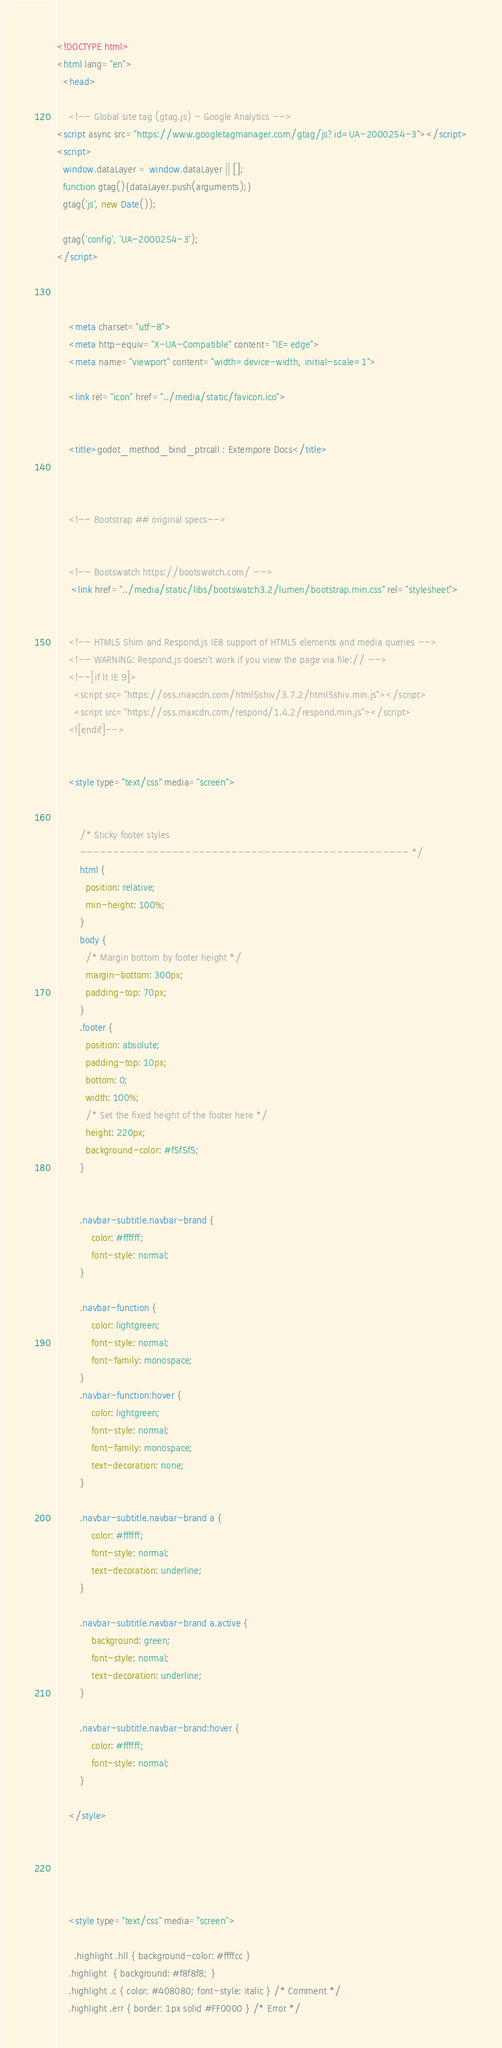Convert code to text. <code><loc_0><loc_0><loc_500><loc_500><_HTML_>




<!DOCTYPE html>
<html lang="en">
  <head>

	<!-- Global site tag (gtag.js) - Google Analytics -->
<script async src="https://www.googletagmanager.com/gtag/js?id=UA-2000254-3"></script>
<script>
  window.dataLayer = window.dataLayer || [];
  function gtag(){dataLayer.push(arguments);}
  gtag('js', new Date());

  gtag('config', 'UA-2000254-3');
</script>



    <meta charset="utf-8">
    <meta http-equiv="X-UA-Compatible" content="IE=edge">
    <meta name="viewport" content="width=device-width, initial-scale=1">

	<link rel="icon" href="../media/static/favicon.ico">
    
	
	<title>godot_method_bind_ptrcall : Extempore Docs</title>

	

    <!-- Bootstrap ## original specs-->
    
	
	<!-- Bootswatch https://bootswatch.com/ -->
	 <link href="../media/static/libs/bootswatch3.2/lumen/bootstrap.min.css" rel="stylesheet">
	 

    <!-- HTML5 Shim and Respond.js IE8 support of HTML5 elements and media queries -->
    <!-- WARNING: Respond.js doesn't work if you view the page via file:// -->
    <!--[if lt IE 9]>
      <script src="https://oss.maxcdn.com/html5shiv/3.7.2/html5shiv.min.js"></script>
      <script src="https://oss.maxcdn.com/respond/1.4.2/respond.min.js"></script>
    <![endif]-->
		
		
	<style type="text/css" media="screen">


		/* Sticky footer styles 
		-------------------------------------------------- */
		html {
		  position: relative;
		  min-height: 100%;
		}
		body {
		  /* Margin bottom by footer height */
		  margin-bottom: 300px;
		  padding-top: 70px;
		}
		.footer {
		  position: absolute;
		  padding-top: 10px;
		  bottom: 0;
		  width: 100%;
		  /* Set the fixed height of the footer here */
		  height: 220px;
		  background-color: #f5f5f5;
		}
		

		.navbar-subtitle.navbar-brand {
			color: #ffffff;
			font-style: normal;
		}

		.navbar-function {
			color: lightgreen;
			font-style: normal;
			font-family: monospace;
		}
		.navbar-function:hover {
			color: lightgreen;
			font-style: normal;
			font-family: monospace;
			text-decoration: none;
		}
		
		.navbar-subtitle.navbar-brand a {
			color: #ffffff;
			font-style: normal;
			text-decoration: underline;
		}

		.navbar-subtitle.navbar-brand a.active {
			background: green;
			font-style: normal;
			text-decoration: underline;
		}

		.navbar-subtitle.navbar-brand:hover {
			color: #ffffff;
			font-style: normal;
		}
		
	</style>	
		
		
	
	
	
	<style type="text/css" media="screen">

	  .highlight .hll { background-color: #ffffcc }
	.highlight  { background: #f8f8f8; }
	.highlight .c { color: #408080; font-style: italic } /* Comment */
	.highlight .err { border: 1px solid #FF0000 } /* Error */</code> 